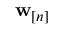<formula> <loc_0><loc_0><loc_500><loc_500>\mathbf w _ { [ n ] }</formula> 